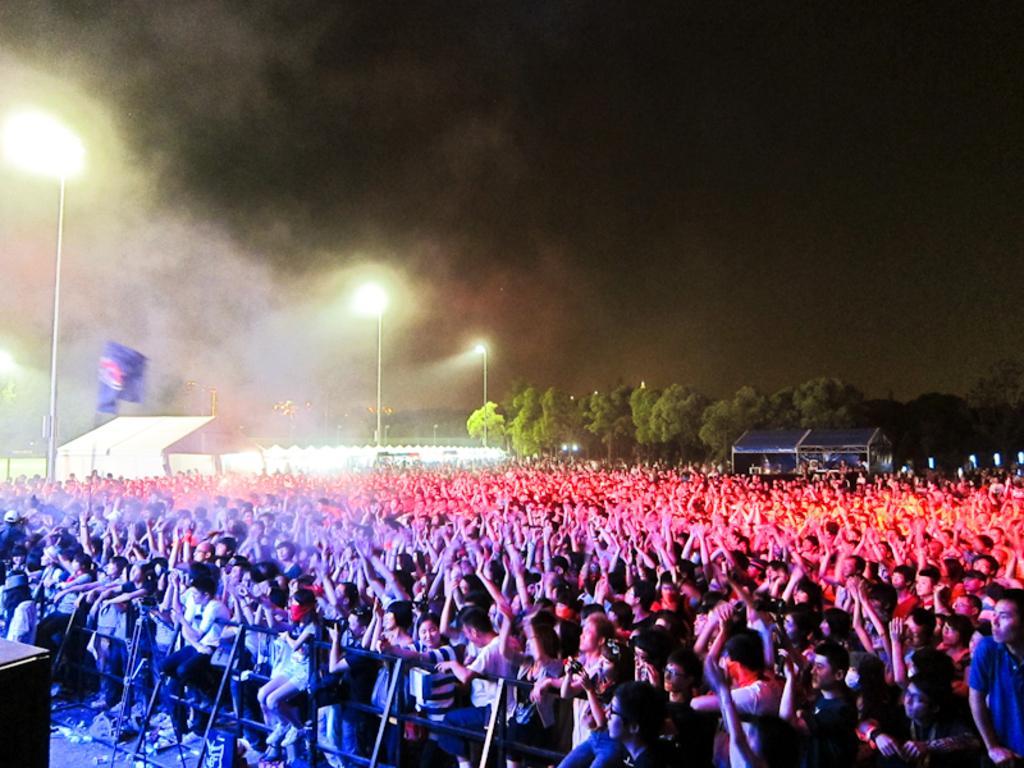How would you summarize this image in a sentence or two? This image consists of a huge crowd. In the front, there is a fencing. On the left, we can see a wooden box. In the background, there are many trees. On the left, there is a flag along with the lights and poles. At the top, there is sky. 